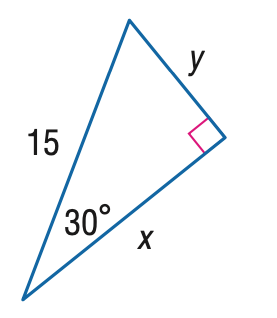Question: Find y.
Choices:
A. \frac { 15 } { 2 }
B. \frac { 15 } { 2 } \sqrt { 2 }
C. \frac { 15 } { 2 } \sqrt { 3 }
D. 15
Answer with the letter. Answer: A 